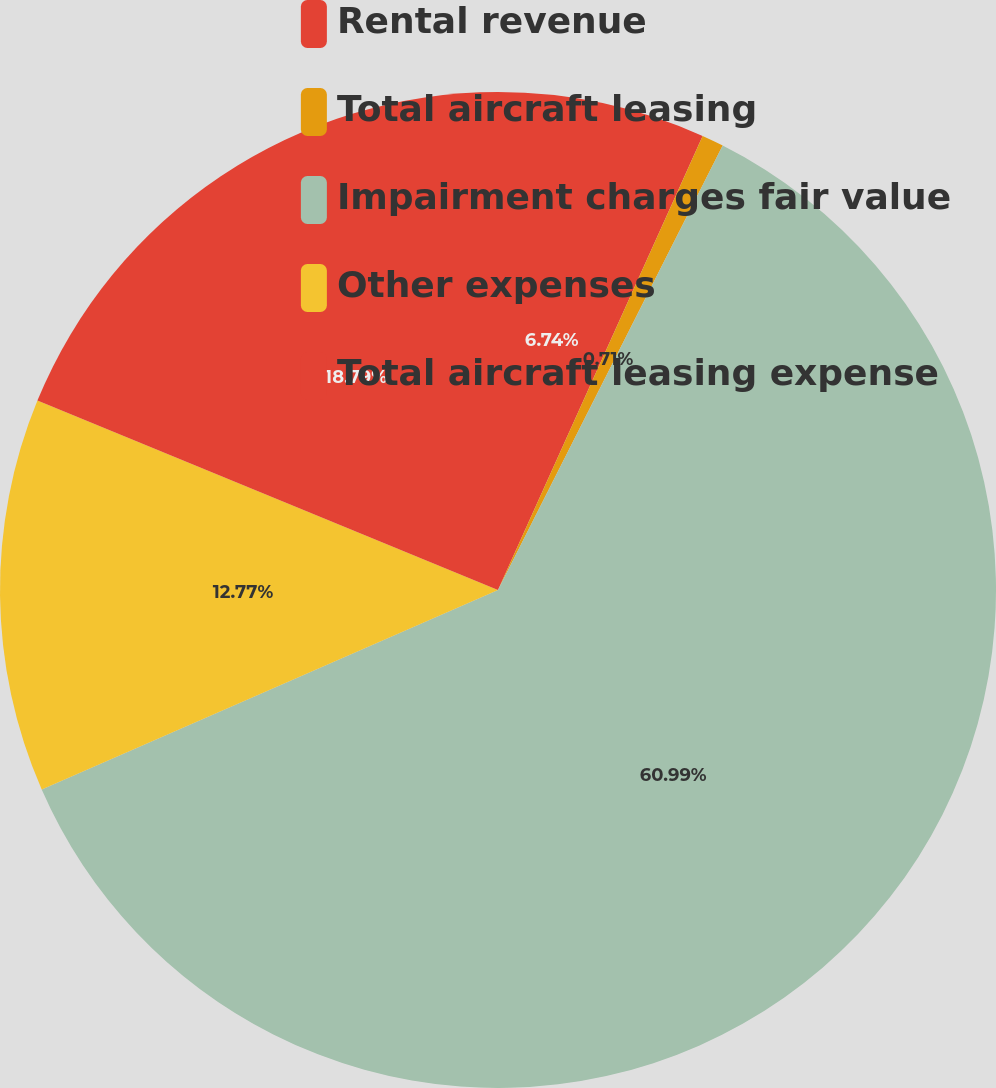Convert chart to OTSL. <chart><loc_0><loc_0><loc_500><loc_500><pie_chart><fcel>Rental revenue<fcel>Total aircraft leasing<fcel>Impairment charges fair value<fcel>Other expenses<fcel>Total aircraft leasing expense<nl><fcel>6.74%<fcel>0.71%<fcel>60.99%<fcel>12.77%<fcel>18.79%<nl></chart> 